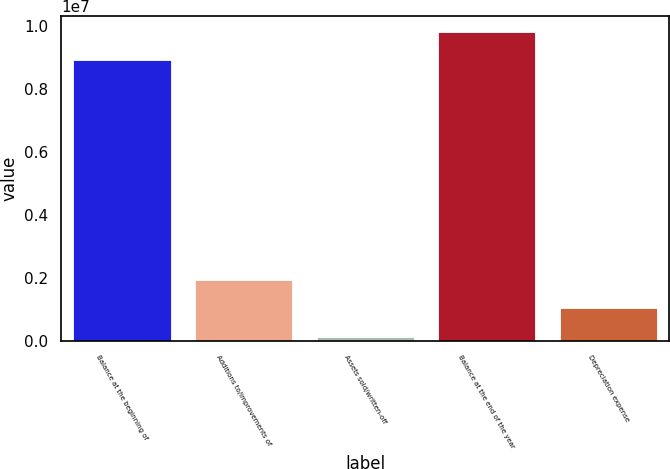Convert chart to OTSL. <chart><loc_0><loc_0><loc_500><loc_500><bar_chart><fcel>Balance at the beginning of<fcel>Additions to/improvements of<fcel>Assets sold/written-off<fcel>Balance at the end of the year<fcel>Depreciation expense<nl><fcel>8.91779e+06<fcel>1.94409e+06<fcel>115955<fcel>9.83185e+06<fcel>1.03002e+06<nl></chart> 